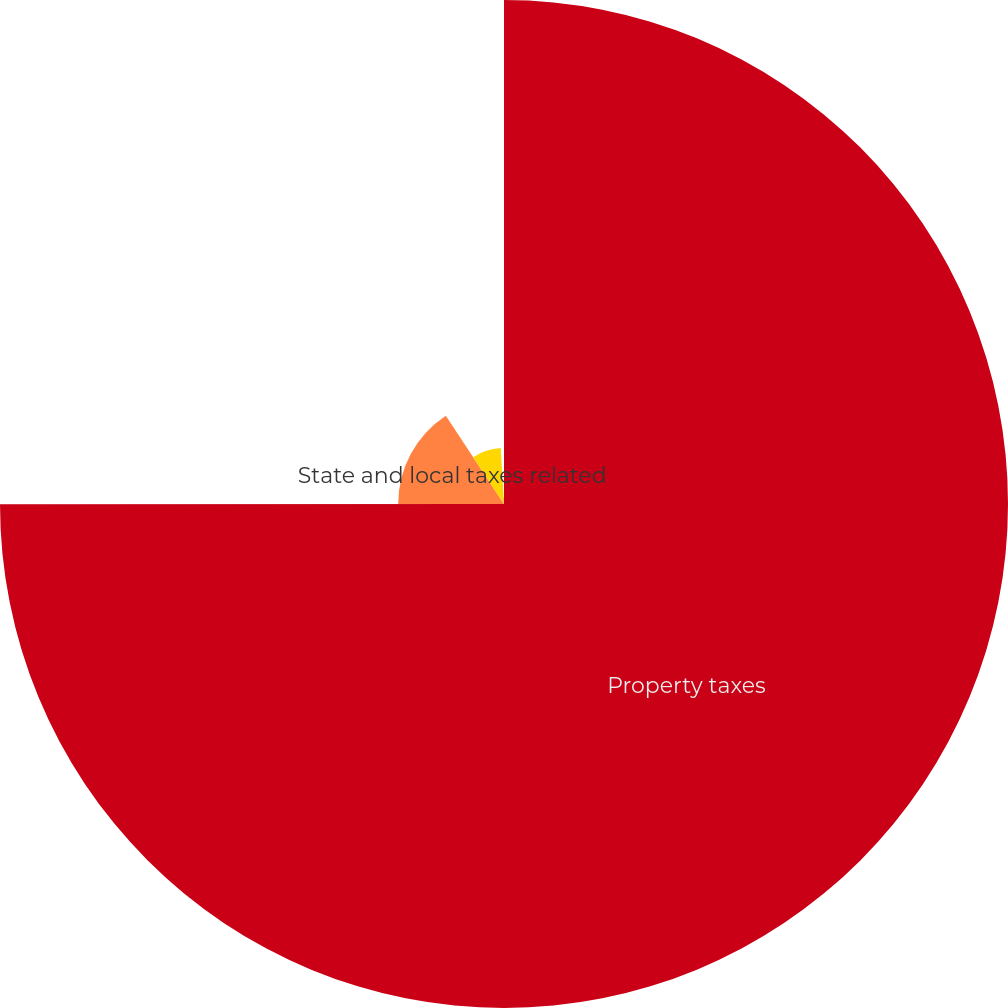<chart> <loc_0><loc_0><loc_500><loc_500><pie_chart><fcel>Property taxes<fcel>State and local taxes related<fcel>Payroll taxes<fcel>Other taxes<nl><fcel>74.99%<fcel>15.74%<fcel>8.34%<fcel>0.93%<nl></chart> 